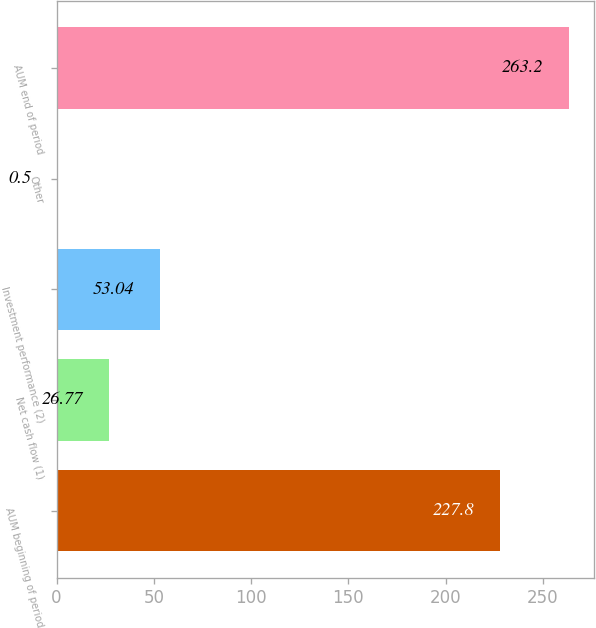Convert chart to OTSL. <chart><loc_0><loc_0><loc_500><loc_500><bar_chart><fcel>AUM beginning of period<fcel>Net cash flow (1)<fcel>Investment performance (2)<fcel>Other<fcel>AUM end of period<nl><fcel>227.8<fcel>26.77<fcel>53.04<fcel>0.5<fcel>263.2<nl></chart> 